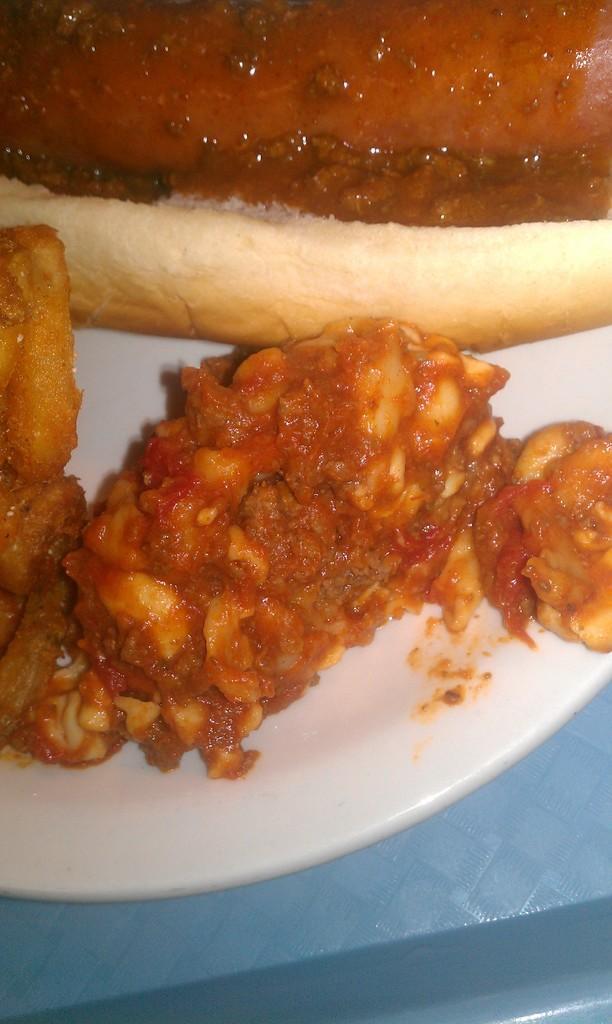In one or two sentences, can you explain what this image depicts? In this picture we can see a white plate on an object and on the plate there is a bread and some food items. 